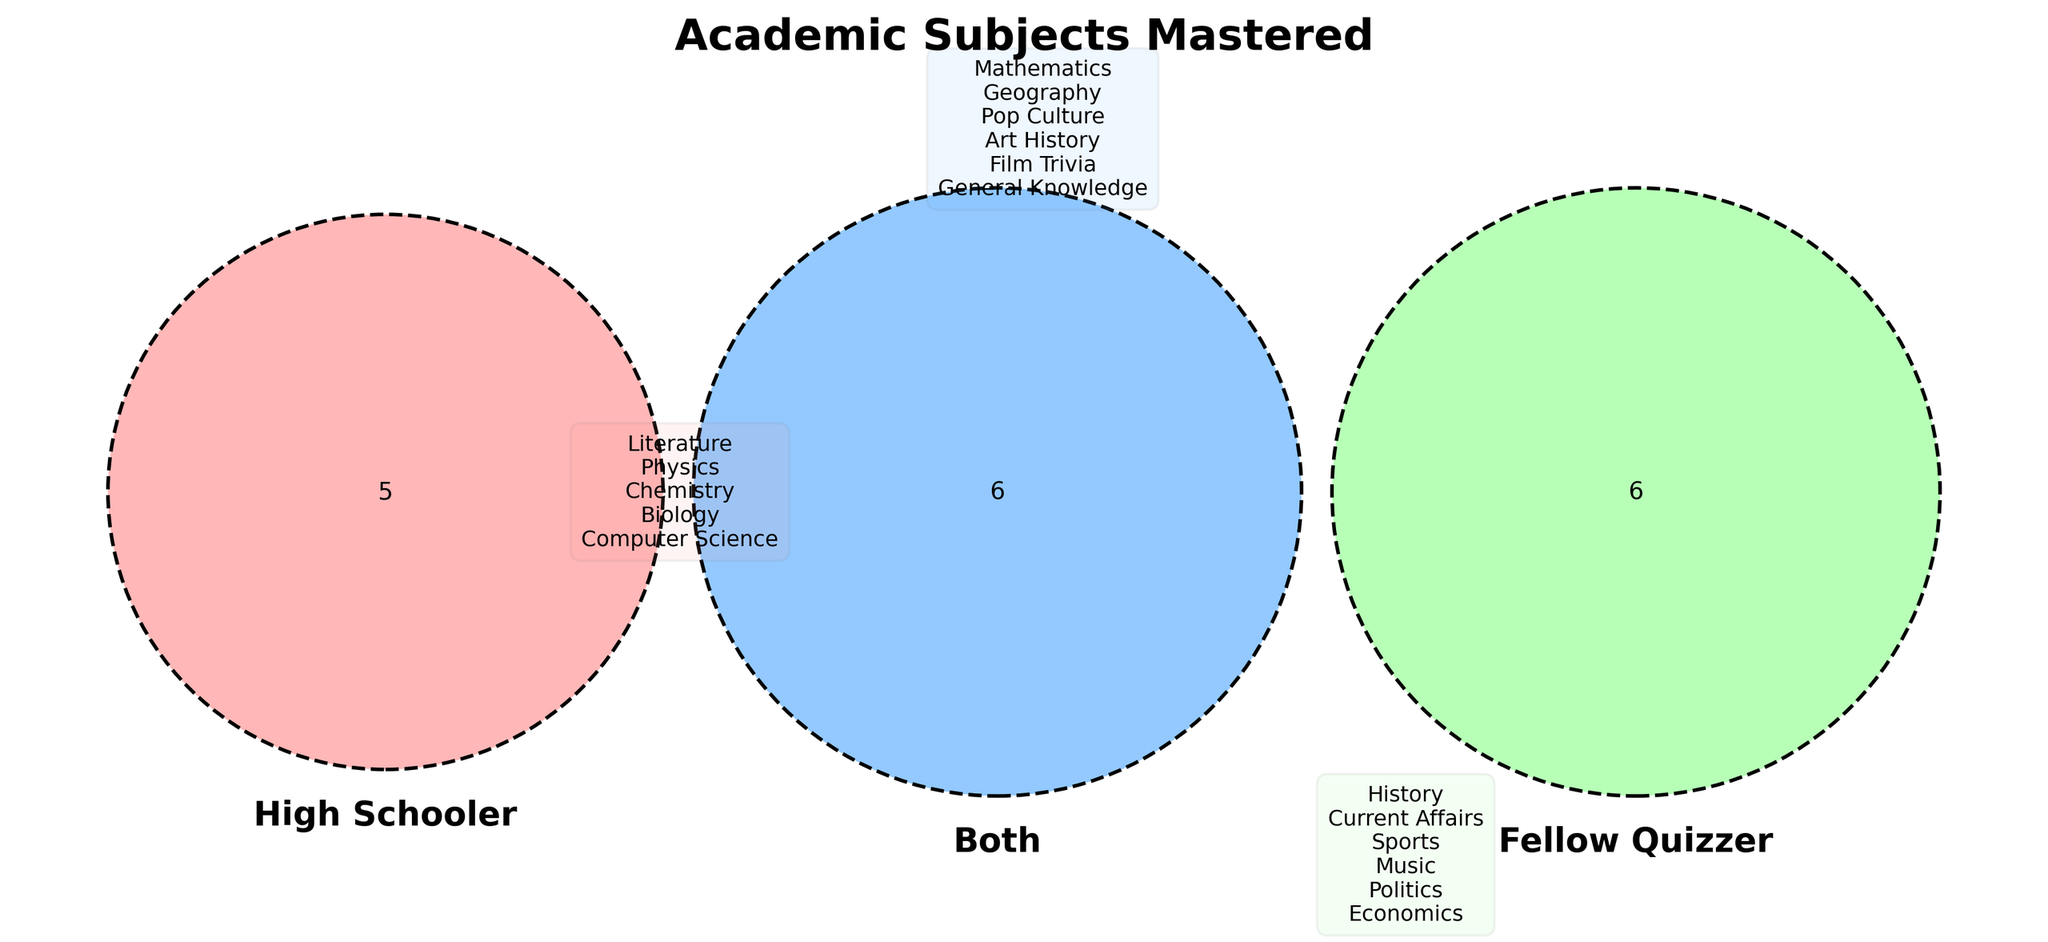What subjects does the High Schooler master? The High Schooler masters the subjects that are only in their circle and not shared with others.
Answer: Literature, Physics, Chemistry, Biology, Computer Science What subjects are shared by both partners? Look at the intersection area labeled "Both" in the Venn Diagram to find the subjects they both master.
Answer: Mathematics, Geography, Pop Culture, Music, Film Trivia, General Knowledge Which subject is only mastered by the Fellow Quizzer? To find the subject only mastered by the Fellow Quizzer, look at their exclusive area in the Venn Diagram.
Answer: History, Current Affairs, Sports, Art History, Politics, Economics How many subjects does the High Schooler master in total? Count all the subjects in the High Schooler's circle, including those shared with both.
Answer: 10 Does the High Schooler master Pop Culture? Identify if Pop Culture is listed in the sections related to the High Schooler’s mastery.
Answer: No Which subjects does neither partner master? Analyze the Venn Diagram to determine if any subjects are outside all circles.
Answer: None What subjects are mastered by only one of the partners? Identify the subjects found in either the High Schooler or Fellow Quizzer circles exclusively, not shared.
Answer: Literature, Physics, Chemistry, Biology, Computer Science, History, Current Affairs, Sports, Art History, Politics, Economics What is unique about Computer Science mastery in the Venn Diagram? Look at the Computer Science subject and see which areas it is in. It should be exclusive to the High Schooler.
Answer: Only mastered by High Schooler Are there more subjects mastered exclusively by the Fellow Quizzer or shared by both? Count subjects in Fellow Quizzer exclusive area and compare with those in shared both area.
Answer: Same (six each) 